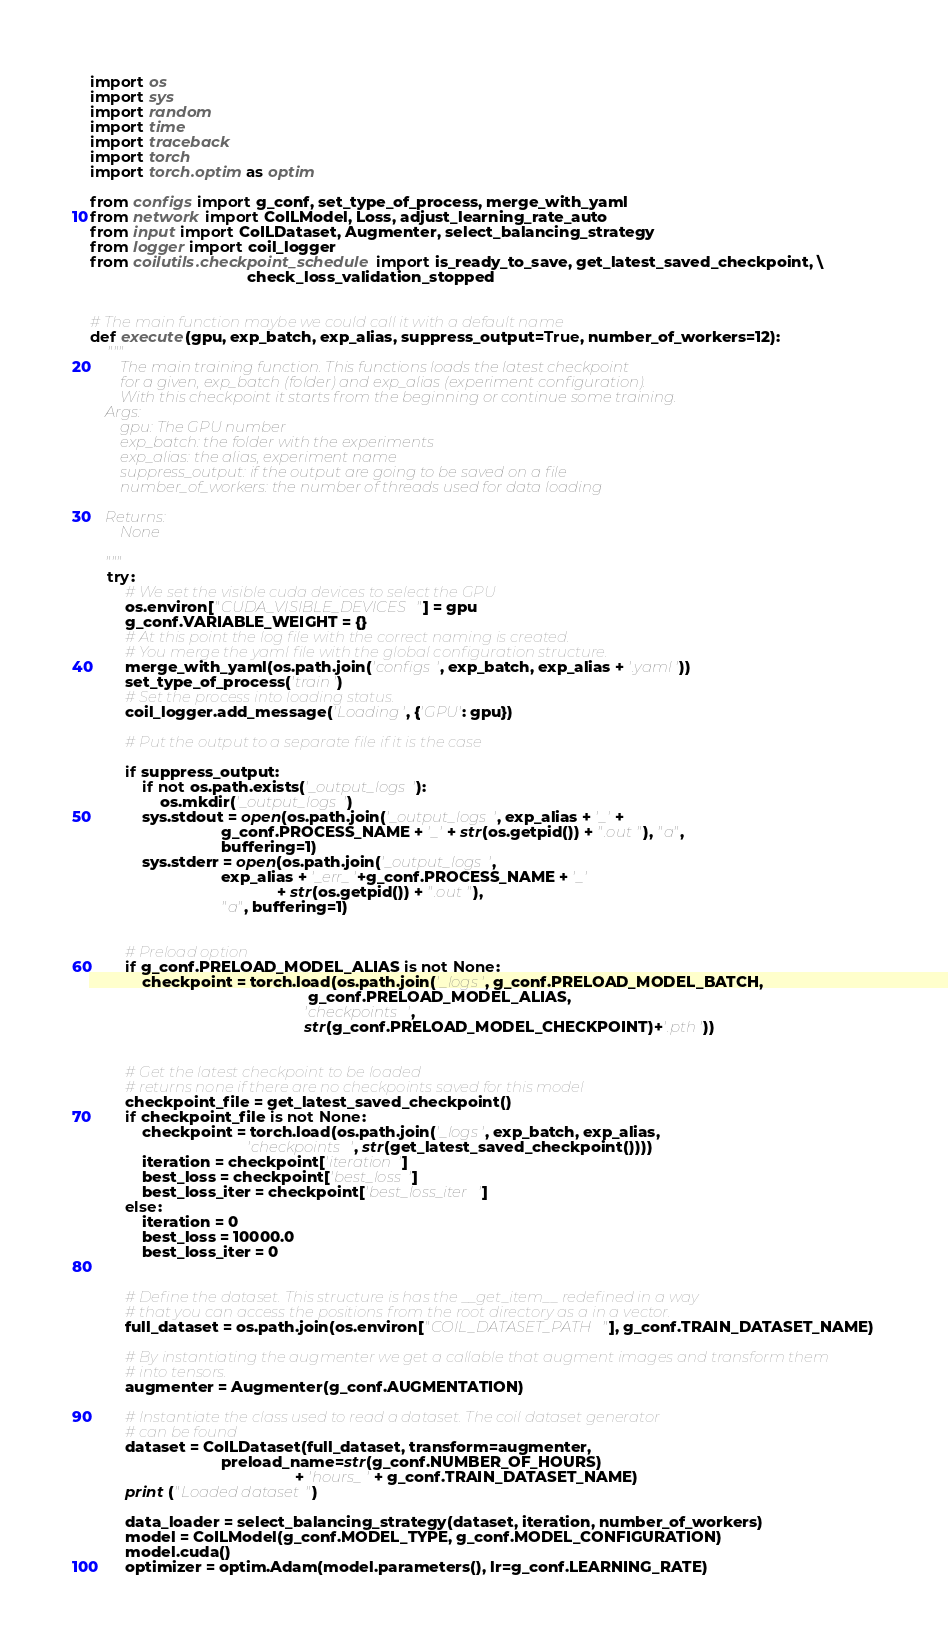<code> <loc_0><loc_0><loc_500><loc_500><_Python_>import os
import sys
import random
import time
import traceback
import torch
import torch.optim as optim

from configs import g_conf, set_type_of_process, merge_with_yaml
from network import CoILModel, Loss, adjust_learning_rate_auto
from input import CoILDataset, Augmenter, select_balancing_strategy
from logger import coil_logger
from coilutils.checkpoint_schedule import is_ready_to_save, get_latest_saved_checkpoint, \
                                    check_loss_validation_stopped


# The main function maybe we could call it with a default name
def execute(gpu, exp_batch, exp_alias, suppress_output=True, number_of_workers=12):
    """
        The main training function. This functions loads the latest checkpoint
        for a given, exp_batch (folder) and exp_alias (experiment configuration).
        With this checkpoint it starts from the beginning or continue some training.
    Args:
        gpu: The GPU number
        exp_batch: the folder with the experiments
        exp_alias: the alias, experiment name
        suppress_output: if the output are going to be saved on a file
        number_of_workers: the number of threads used for data loading

    Returns:
        None

    """
    try:
        # We set the visible cuda devices to select the GPU
        os.environ["CUDA_VISIBLE_DEVICES"] = gpu
        g_conf.VARIABLE_WEIGHT = {}
        # At this point the log file with the correct naming is created.
        # You merge the yaml file with the global configuration structure.
        merge_with_yaml(os.path.join('configs', exp_batch, exp_alias + '.yaml'))
        set_type_of_process('train')
        # Set the process into loading status.
        coil_logger.add_message('Loading', {'GPU': gpu})

        # Put the output to a separate file if it is the case

        if suppress_output:
            if not os.path.exists('_output_logs'):
                os.mkdir('_output_logs')
            sys.stdout = open(os.path.join('_output_logs', exp_alias + '_' +
                              g_conf.PROCESS_NAME + '_' + str(os.getpid()) + ".out"), "a",
                              buffering=1)
            sys.stderr = open(os.path.join('_output_logs',
                              exp_alias + '_err_'+g_conf.PROCESS_NAME + '_'
                                           + str(os.getpid()) + ".out"),
                              "a", buffering=1)
        

        # Preload option
        if g_conf.PRELOAD_MODEL_ALIAS is not None:
            checkpoint = torch.load(os.path.join('_logs', g_conf.PRELOAD_MODEL_BATCH,
                                                  g_conf.PRELOAD_MODEL_ALIAS,
                                                 'checkpoints',
                                                 str(g_conf.PRELOAD_MODEL_CHECKPOINT)+'.pth'))


        # Get the latest checkpoint to be loaded
        # returns none if there are no checkpoints saved for this model
        checkpoint_file = get_latest_saved_checkpoint()
        if checkpoint_file is not None:
            checkpoint = torch.load(os.path.join('_logs', exp_batch, exp_alias,
                                    'checkpoints', str(get_latest_saved_checkpoint())))
            iteration = checkpoint['iteration']
            best_loss = checkpoint['best_loss']
            best_loss_iter = checkpoint['best_loss_iter']
        else:
            iteration = 0
            best_loss = 10000.0
            best_loss_iter = 0


        # Define the dataset. This structure is has the __get_item__ redefined in a way
        # that you can access the positions from the root directory as a in a vector.
        full_dataset = os.path.join(os.environ["COIL_DATASET_PATH"], g_conf.TRAIN_DATASET_NAME)

        # By instantiating the augmenter we get a callable that augment images and transform them
        # into tensors.
        augmenter = Augmenter(g_conf.AUGMENTATION)

        # Instantiate the class used to read a dataset. The coil dataset generator
        # can be found
        dataset = CoILDataset(full_dataset, transform=augmenter,
                              preload_name=str(g_conf.NUMBER_OF_HOURS)
                                               + 'hours_' + g_conf.TRAIN_DATASET_NAME)
        print ("Loaded dataset")

        data_loader = select_balancing_strategy(dataset, iteration, number_of_workers)
        model = CoILModel(g_conf.MODEL_TYPE, g_conf.MODEL_CONFIGURATION)
        model.cuda()
        optimizer = optim.Adam(model.parameters(), lr=g_conf.LEARNING_RATE)
</code> 